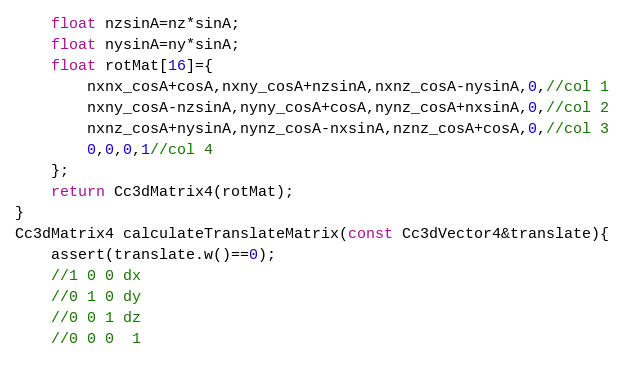<code> <loc_0><loc_0><loc_500><loc_500><_C++_>    float nzsinA=nz*sinA;
    float nysinA=ny*sinA;
    float rotMat[16]={
        nxnx_cosA+cosA,nxny_cosA+nzsinA,nxnz_cosA-nysinA,0,//col 1
        nxny_cosA-nzsinA,nyny_cosA+cosA,nynz_cosA+nxsinA,0,//col 2
        nxnz_cosA+nysinA,nynz_cosA-nxsinA,nznz_cosA+cosA,0,//col 3
        0,0,0,1//col 4
    };
    return Cc3dMatrix4(rotMat);
}
Cc3dMatrix4 calculateTranslateMatrix(const Cc3dVector4&translate){
    assert(translate.w()==0);
    //1 0 0 dx
    //0 1 0 dy
    //0 0 1 dz
    //0 0 0  1</code> 